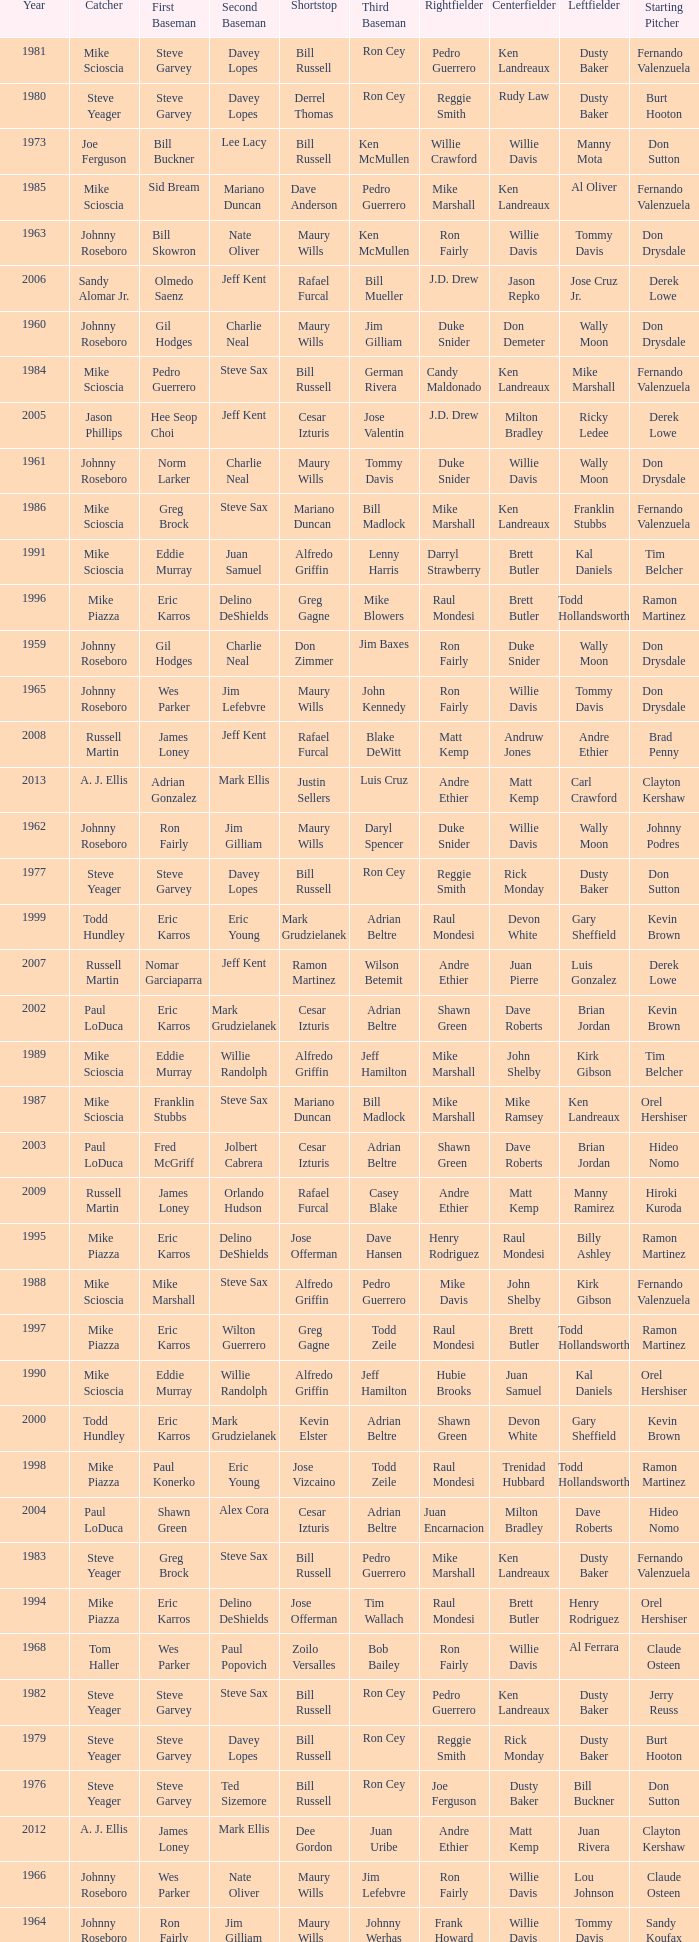Can you parse all the data within this table? {'header': ['Year', 'Catcher', 'First Baseman', 'Second Baseman', 'Shortstop', 'Third Baseman', 'Rightfielder', 'Centerfielder', 'Leftfielder', 'Starting Pitcher'], 'rows': [['1981', 'Mike Scioscia', 'Steve Garvey', 'Davey Lopes', 'Bill Russell', 'Ron Cey', 'Pedro Guerrero', 'Ken Landreaux', 'Dusty Baker', 'Fernando Valenzuela'], ['1980', 'Steve Yeager', 'Steve Garvey', 'Davey Lopes', 'Derrel Thomas', 'Ron Cey', 'Reggie Smith', 'Rudy Law', 'Dusty Baker', 'Burt Hooton'], ['1973', 'Joe Ferguson', 'Bill Buckner', 'Lee Lacy', 'Bill Russell', 'Ken McMullen', 'Willie Crawford', 'Willie Davis', 'Manny Mota', 'Don Sutton'], ['1985', 'Mike Scioscia', 'Sid Bream', 'Mariano Duncan', 'Dave Anderson', 'Pedro Guerrero', 'Mike Marshall', 'Ken Landreaux', 'Al Oliver', 'Fernando Valenzuela'], ['1963', 'Johnny Roseboro', 'Bill Skowron', 'Nate Oliver', 'Maury Wills', 'Ken McMullen', 'Ron Fairly', 'Willie Davis', 'Tommy Davis', 'Don Drysdale'], ['2006', 'Sandy Alomar Jr.', 'Olmedo Saenz', 'Jeff Kent', 'Rafael Furcal', 'Bill Mueller', 'J.D. Drew', 'Jason Repko', 'Jose Cruz Jr.', 'Derek Lowe'], ['1960', 'Johnny Roseboro', 'Gil Hodges', 'Charlie Neal', 'Maury Wills', 'Jim Gilliam', 'Duke Snider', 'Don Demeter', 'Wally Moon', 'Don Drysdale'], ['1984', 'Mike Scioscia', 'Pedro Guerrero', 'Steve Sax', 'Bill Russell', 'German Rivera', 'Candy Maldonado', 'Ken Landreaux', 'Mike Marshall', 'Fernando Valenzuela'], ['2005', 'Jason Phillips', 'Hee Seop Choi', 'Jeff Kent', 'Cesar Izturis', 'Jose Valentin', 'J.D. Drew', 'Milton Bradley', 'Ricky Ledee', 'Derek Lowe'], ['1961', 'Johnny Roseboro', 'Norm Larker', 'Charlie Neal', 'Maury Wills', 'Tommy Davis', 'Duke Snider', 'Willie Davis', 'Wally Moon', 'Don Drysdale'], ['1986', 'Mike Scioscia', 'Greg Brock', 'Steve Sax', 'Mariano Duncan', 'Bill Madlock', 'Mike Marshall', 'Ken Landreaux', 'Franklin Stubbs', 'Fernando Valenzuela'], ['1991', 'Mike Scioscia', 'Eddie Murray', 'Juan Samuel', 'Alfredo Griffin', 'Lenny Harris', 'Darryl Strawberry', 'Brett Butler', 'Kal Daniels', 'Tim Belcher'], ['1996', 'Mike Piazza', 'Eric Karros', 'Delino DeShields', 'Greg Gagne', 'Mike Blowers', 'Raul Mondesi', 'Brett Butler', 'Todd Hollandsworth', 'Ramon Martinez'], ['1959', 'Johnny Roseboro', 'Gil Hodges', 'Charlie Neal', 'Don Zimmer', 'Jim Baxes', 'Ron Fairly', 'Duke Snider', 'Wally Moon', 'Don Drysdale'], ['1965', 'Johnny Roseboro', 'Wes Parker', 'Jim Lefebvre', 'Maury Wills', 'John Kennedy', 'Ron Fairly', 'Willie Davis', 'Tommy Davis', 'Don Drysdale'], ['2008', 'Russell Martin', 'James Loney', 'Jeff Kent', 'Rafael Furcal', 'Blake DeWitt', 'Matt Kemp', 'Andruw Jones', 'Andre Ethier', 'Brad Penny'], ['2013', 'A. J. Ellis', 'Adrian Gonzalez', 'Mark Ellis', 'Justin Sellers', 'Luis Cruz', 'Andre Ethier', 'Matt Kemp', 'Carl Crawford', 'Clayton Kershaw'], ['1962', 'Johnny Roseboro', 'Ron Fairly', 'Jim Gilliam', 'Maury Wills', 'Daryl Spencer', 'Duke Snider', 'Willie Davis', 'Wally Moon', 'Johnny Podres'], ['1977', 'Steve Yeager', 'Steve Garvey', 'Davey Lopes', 'Bill Russell', 'Ron Cey', 'Reggie Smith', 'Rick Monday', 'Dusty Baker', 'Don Sutton'], ['1999', 'Todd Hundley', 'Eric Karros', 'Eric Young', 'Mark Grudzielanek', 'Adrian Beltre', 'Raul Mondesi', 'Devon White', 'Gary Sheffield', 'Kevin Brown'], ['2007', 'Russell Martin', 'Nomar Garciaparra', 'Jeff Kent', 'Ramon Martinez', 'Wilson Betemit', 'Andre Ethier', 'Juan Pierre', 'Luis Gonzalez', 'Derek Lowe'], ['2002', 'Paul LoDuca', 'Eric Karros', 'Mark Grudzielanek', 'Cesar Izturis', 'Adrian Beltre', 'Shawn Green', 'Dave Roberts', 'Brian Jordan', 'Kevin Brown'], ['1989', 'Mike Scioscia', 'Eddie Murray', 'Willie Randolph', 'Alfredo Griffin', 'Jeff Hamilton', 'Mike Marshall', 'John Shelby', 'Kirk Gibson', 'Tim Belcher'], ['1987', 'Mike Scioscia', 'Franklin Stubbs', 'Steve Sax', 'Mariano Duncan', 'Bill Madlock', 'Mike Marshall', 'Mike Ramsey', 'Ken Landreaux', 'Orel Hershiser'], ['2003', 'Paul LoDuca', 'Fred McGriff', 'Jolbert Cabrera', 'Cesar Izturis', 'Adrian Beltre', 'Shawn Green', 'Dave Roberts', 'Brian Jordan', 'Hideo Nomo'], ['2009', 'Russell Martin', 'James Loney', 'Orlando Hudson', 'Rafael Furcal', 'Casey Blake', 'Andre Ethier', 'Matt Kemp', 'Manny Ramirez', 'Hiroki Kuroda'], ['1995', 'Mike Piazza', 'Eric Karros', 'Delino DeShields', 'Jose Offerman', 'Dave Hansen', 'Henry Rodriguez', 'Raul Mondesi', 'Billy Ashley', 'Ramon Martinez'], ['1988', 'Mike Scioscia', 'Mike Marshall', 'Steve Sax', 'Alfredo Griffin', 'Pedro Guerrero', 'Mike Davis', 'John Shelby', 'Kirk Gibson', 'Fernando Valenzuela'], ['1997', 'Mike Piazza', 'Eric Karros', 'Wilton Guerrero', 'Greg Gagne', 'Todd Zeile', 'Raul Mondesi', 'Brett Butler', 'Todd Hollandsworth', 'Ramon Martinez'], ['1990', 'Mike Scioscia', 'Eddie Murray', 'Willie Randolph', 'Alfredo Griffin', 'Jeff Hamilton', 'Hubie Brooks', 'Juan Samuel', 'Kal Daniels', 'Orel Hershiser'], ['2000', 'Todd Hundley', 'Eric Karros', 'Mark Grudzielanek', 'Kevin Elster', 'Adrian Beltre', 'Shawn Green', 'Devon White', 'Gary Sheffield', 'Kevin Brown'], ['1998', 'Mike Piazza', 'Paul Konerko', 'Eric Young', 'Jose Vizcaino', 'Todd Zeile', 'Raul Mondesi', 'Trenidad Hubbard', 'Todd Hollandsworth', 'Ramon Martinez'], ['2004', 'Paul LoDuca', 'Shawn Green', 'Alex Cora', 'Cesar Izturis', 'Adrian Beltre', 'Juan Encarnacion', 'Milton Bradley', 'Dave Roberts', 'Hideo Nomo'], ['1983', 'Steve Yeager', 'Greg Brock', 'Steve Sax', 'Bill Russell', 'Pedro Guerrero', 'Mike Marshall', 'Ken Landreaux', 'Dusty Baker', 'Fernando Valenzuela'], ['1994', 'Mike Piazza', 'Eric Karros', 'Delino DeShields', 'Jose Offerman', 'Tim Wallach', 'Raul Mondesi', 'Brett Butler', 'Henry Rodriguez', 'Orel Hershiser'], ['1968', 'Tom Haller', 'Wes Parker', 'Paul Popovich', 'Zoilo Versalles', 'Bob Bailey', 'Ron Fairly', 'Willie Davis', 'Al Ferrara', 'Claude Osteen'], ['1982', 'Steve Yeager', 'Steve Garvey', 'Steve Sax', 'Bill Russell', 'Ron Cey', 'Pedro Guerrero', 'Ken Landreaux', 'Dusty Baker', 'Jerry Reuss'], ['1979', 'Steve Yeager', 'Steve Garvey', 'Davey Lopes', 'Bill Russell', 'Ron Cey', 'Reggie Smith', 'Rick Monday', 'Dusty Baker', 'Burt Hooton'], ['1976', 'Steve Yeager', 'Steve Garvey', 'Ted Sizemore', 'Bill Russell', 'Ron Cey', 'Joe Ferguson', 'Dusty Baker', 'Bill Buckner', 'Don Sutton'], ['2012', 'A. J. Ellis', 'James Loney', 'Mark Ellis', 'Dee Gordon', 'Juan Uribe', 'Andre Ethier', 'Matt Kemp', 'Juan Rivera', 'Clayton Kershaw'], ['1966', 'Johnny Roseboro', 'Wes Parker', 'Nate Oliver', 'Maury Wills', 'Jim Lefebvre', 'Ron Fairly', 'Willie Davis', 'Lou Johnson', 'Claude Osteen'], ['1964', 'Johnny Roseboro', 'Ron Fairly', 'Jim Gilliam', 'Maury Wills', 'Johnny Werhas', 'Frank Howard', 'Willie Davis', 'Tommy Davis', 'Sandy Koufax'], ['1992', 'Mike Scioscia', 'Kal Daniels', 'Juan Samuel', 'Jose Offerman', 'Lenny Harris', 'Darryl Strawberry', 'Brett Butler', 'Eric Davis', 'Ramon Martinez'], ['2011', 'Rod Barajas', 'James Loney', 'Jamey Carroll', 'Rafael Furcal', 'Juan Uribe', 'Andre Ethier', 'Matt Kemp', 'Tony Gwynn, Jr.', 'Clayton Kershaw'], ['1974', 'Joe Ferguson', 'Bill Buckner', 'Davey Lopes', 'Bill Russell', 'Ron Cey', 'Willie Crawford', 'Jimmy Wynn', 'Von Joshua', 'Don Sutton'], ['1978', 'Steve Yeager', 'Steve Garvey', 'Davey Lopes', 'Bill Russell', 'Ron Cey', 'Reggie Smith', 'Rick Monday', 'Dusty Baker', 'Don Sutton'], ['1971', 'Duke Sims', 'Wes Parker', 'Bill Russell', 'Maury Wills', 'Steve Garvey', 'Bill Buckner', 'Willie Davis', 'Dick Allen', 'Bill Singer'], ['2001', 'Chad Kreuter', 'Eric Karros', 'Mark Grudzielanek', 'Cesar Izturis', 'Chris Donnels', 'Shawn Green', 'Tom Goodwin', 'Gary Sheffield', 'Chan Ho Park'], ['2010', 'Russell Martin', 'James Loney', 'Blake DeWitt', 'Rafael Furcal', 'Casey Blake', 'Andre Ethier', 'Matt Kemp', 'Manny Ramirez', 'Vicente Padilla'], ['1993', 'Mike Piazza', 'Eric Karros', 'Jody Reed', 'Jose Offerman', 'Tim Wallach', 'Darryl Strawberry', 'Brett Butler', 'Eric Davis', 'Orel Hershiser'], ['1970', 'Tom Haller', 'Wes Parker', 'Ted Sizemore', 'Maury Wills', 'Steve Garvey', 'Willie Crawford', 'Willie Davis', 'Bill Buckner', 'Claude Osteen'], ['1975', 'Steve Yeager', 'Steve Garvey', 'Davey Lopes', 'Bill Russell', 'Ron Cey', 'Joe Ferguson', 'Jimmy Wynn', 'Bill Buckner', 'Don Sutton'], ['1972', 'Duke Sims', 'Bill Buckner', 'Jim Lefebvre', 'Maury Wills', 'Billy Grabarkewitz', 'Frank Robinson', 'Willie Davis', 'Willie Crawford', 'Don Sutton'], ['1969', 'Tom Haller', 'Ron Fairly', 'Jim Lefebvre', 'Ted Sizemore', 'Bill Sudakis', 'Len Gabrielson', 'Willie Crawford', 'Andy Kosco', 'Don Drysdale'], ['1967', 'Johnny Roseboro', 'Ron Fairly', 'Ron Hunt', 'Gene Michael', 'Jim Lefebvre', 'Lou Johnson', 'Wes Parker', 'Bob Bailey', 'Bob Miller']]} Who played 2nd base when nomar garciaparra was at 1st base? Jeff Kent. 